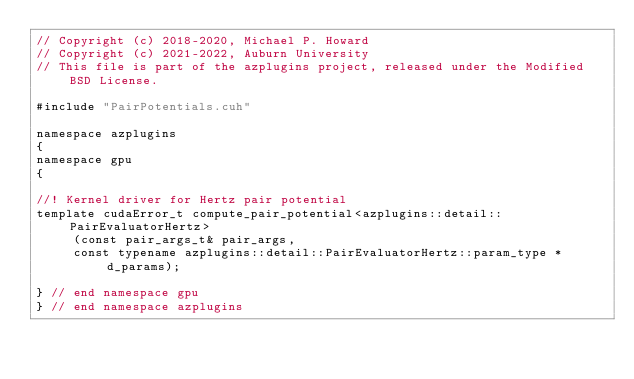<code> <loc_0><loc_0><loc_500><loc_500><_Cuda_>// Copyright (c) 2018-2020, Michael P. Howard
// Copyright (c) 2021-2022, Auburn University
// This file is part of the azplugins project, released under the Modified BSD License.

#include "PairPotentials.cuh"

namespace azplugins
{
namespace gpu
{

//! Kernel driver for Hertz pair potential
template cudaError_t compute_pair_potential<azplugins::detail::PairEvaluatorHertz>
     (const pair_args_t& pair_args,
     const typename azplugins::detail::PairEvaluatorHertz::param_type *d_params);

} // end namespace gpu
} // end namespace azplugins
</code> 